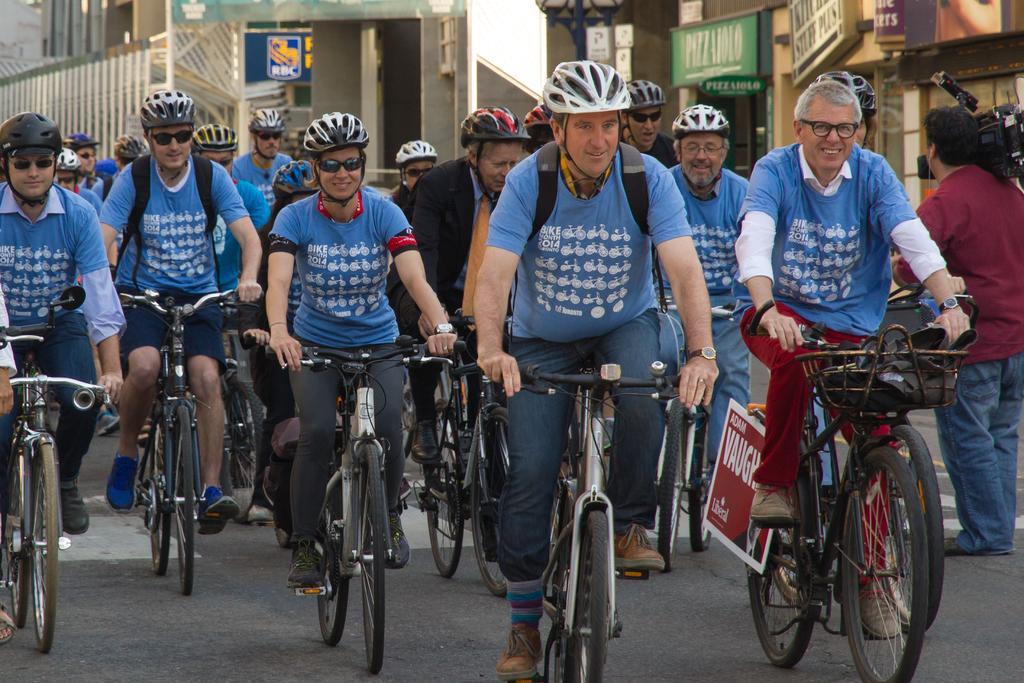Describe this image in one or two sentences. In this image I can see people riding bicycles and they are wearing blue t shirt and helmets. A person is standing on the right, holding a camera. A person is wearing a suit in the center. There are buildings at the back. 